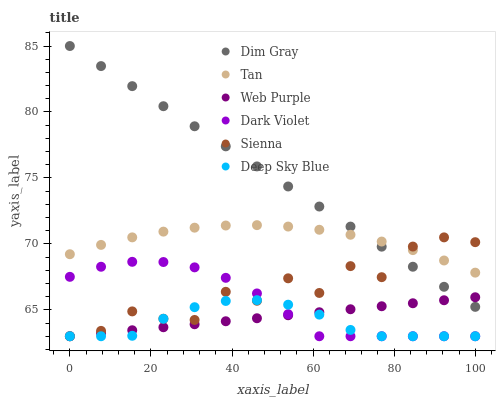Does Deep Sky Blue have the minimum area under the curve?
Answer yes or no. Yes. Does Dim Gray have the maximum area under the curve?
Answer yes or no. Yes. Does Dark Violet have the minimum area under the curve?
Answer yes or no. No. Does Dark Violet have the maximum area under the curve?
Answer yes or no. No. Is Web Purple the smoothest?
Answer yes or no. Yes. Is Sienna the roughest?
Answer yes or no. Yes. Is Dark Violet the smoothest?
Answer yes or no. No. Is Dark Violet the roughest?
Answer yes or no. No. Does Dark Violet have the lowest value?
Answer yes or no. Yes. Does Tan have the lowest value?
Answer yes or no. No. Does Dim Gray have the highest value?
Answer yes or no. Yes. Does Dark Violet have the highest value?
Answer yes or no. No. Is Dark Violet less than Tan?
Answer yes or no. Yes. Is Dim Gray greater than Deep Sky Blue?
Answer yes or no. Yes. Does Web Purple intersect Sienna?
Answer yes or no. Yes. Is Web Purple less than Sienna?
Answer yes or no. No. Is Web Purple greater than Sienna?
Answer yes or no. No. Does Dark Violet intersect Tan?
Answer yes or no. No. 